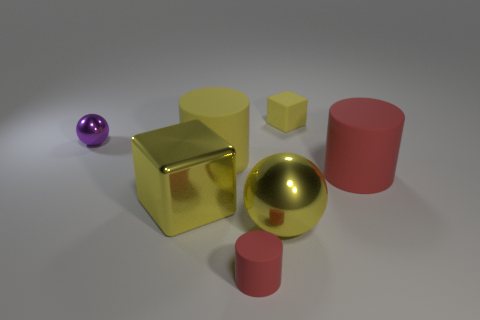Subtract all large cylinders. How many cylinders are left? 1 Subtract all gray balls. How many red cylinders are left? 2 Add 3 tiny blocks. How many objects exist? 10 Subtract all red cylinders. How many cylinders are left? 1 Subtract 0 gray cubes. How many objects are left? 7 Subtract all blocks. How many objects are left? 5 Subtract 1 cylinders. How many cylinders are left? 2 Subtract all red blocks. Subtract all blue balls. How many blocks are left? 2 Subtract all small red things. Subtract all rubber cubes. How many objects are left? 5 Add 2 small yellow cubes. How many small yellow cubes are left? 3 